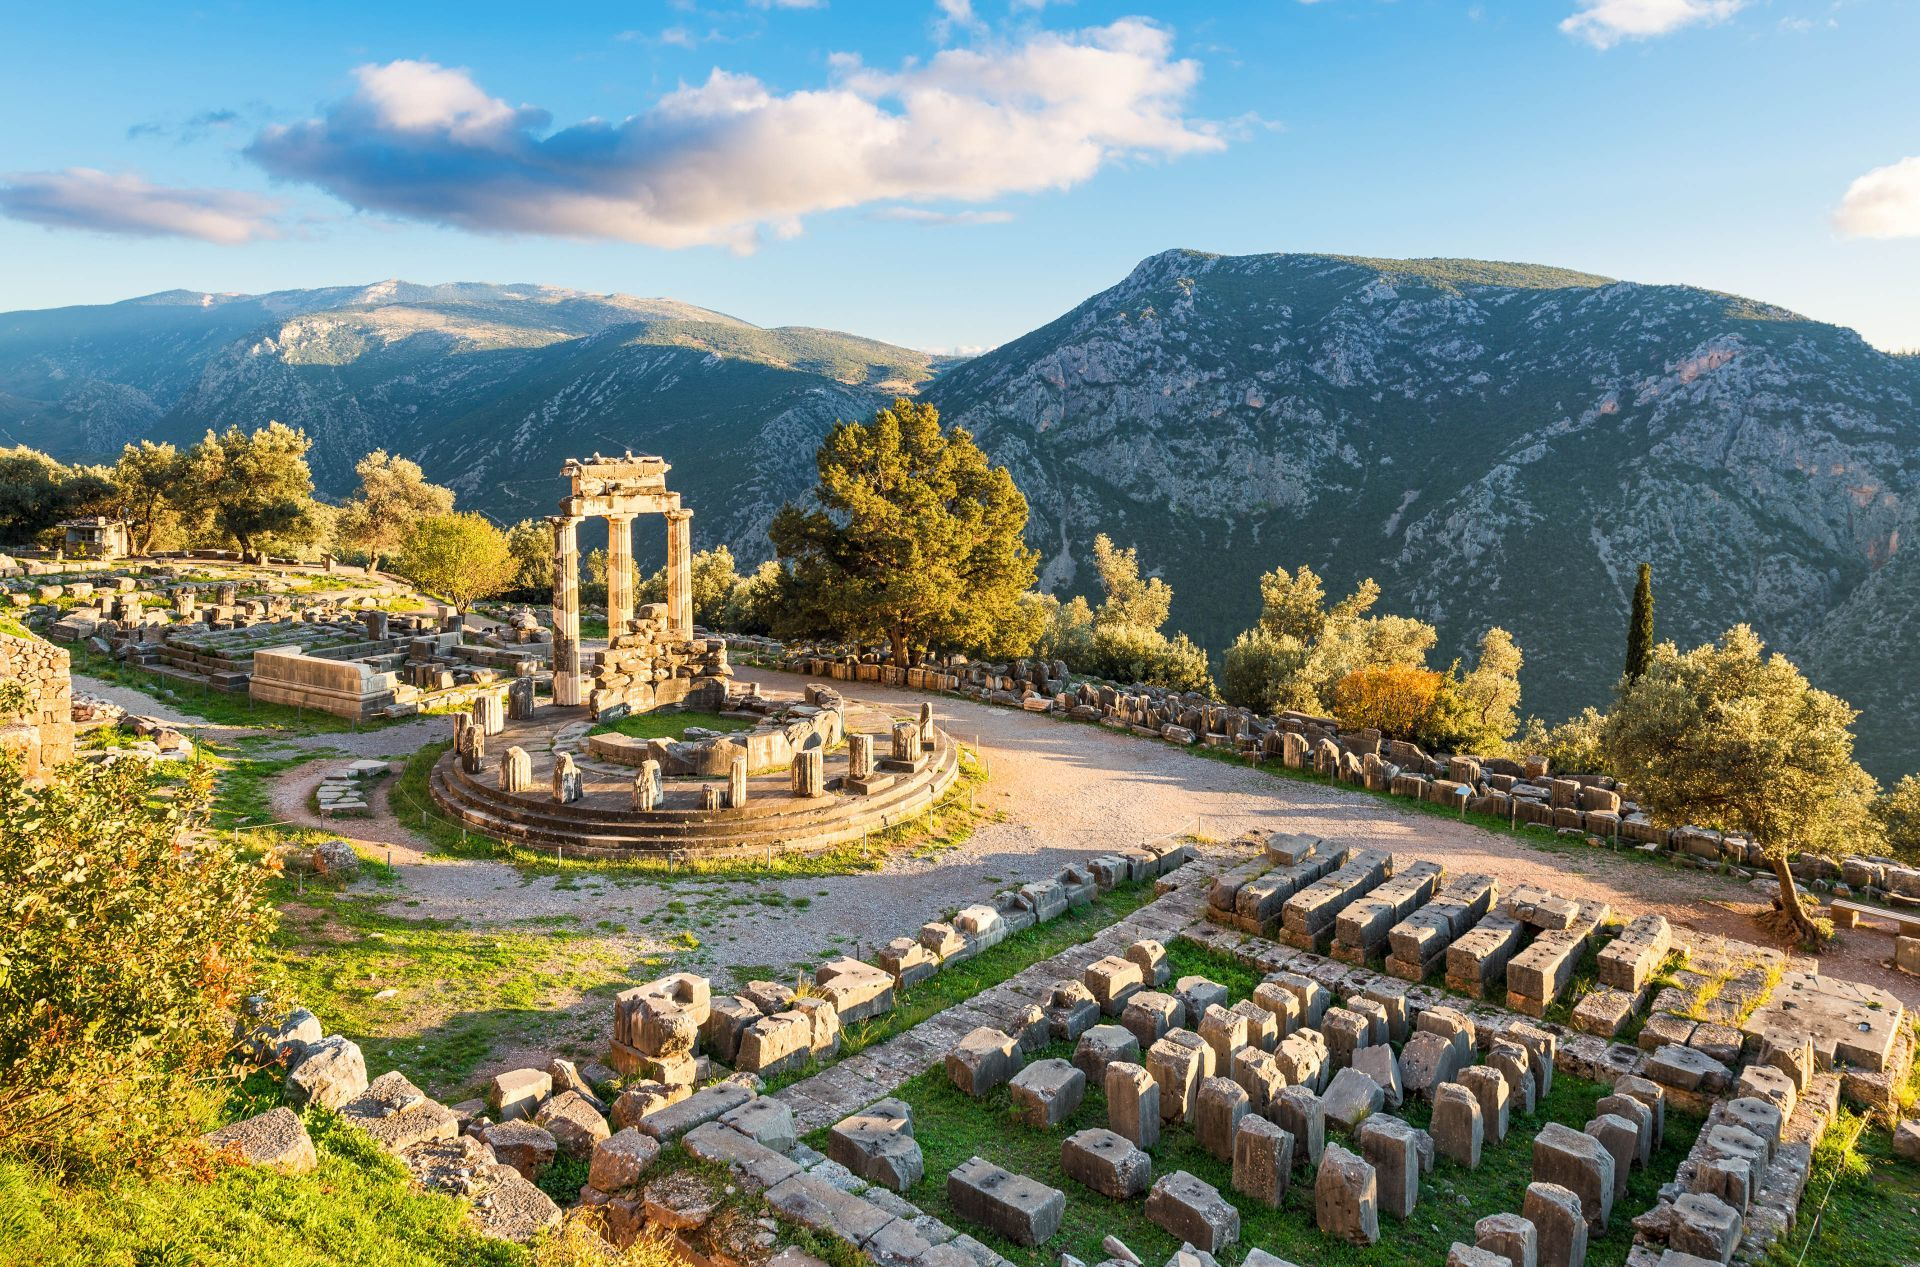What do you think is going on in this snapshot? The image beautifully captures the ancient site of Delphi, one of the most significant archaeological sites in Greece, known as the center of worship of the god Apollo. The ruins shown include the well-preserved Tholos at the sanctuary of Athena Pronaia and the Temple of Apollo, famous for hosting the Pythian oracle. This photograph, taken during the golden hour, highlights the site's majestic setting against a backdrop of Mount Parnassus, enhancing the mystical and historical ambiance that Delphi is celebrated for. This place, rich in mythology and history, was considered the center of the world in ancient Greek religion and played a crucial role in the classical Greek world. 